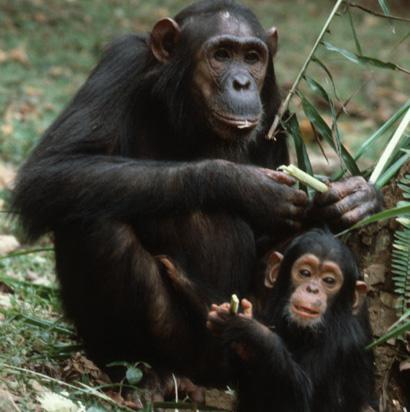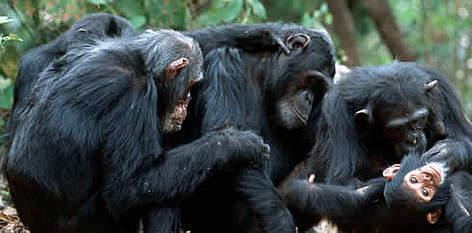The first image is the image on the left, the second image is the image on the right. Assess this claim about the two images: "there is exactly one animal in the image on the left". Correct or not? Answer yes or no. No. The first image is the image on the left, the second image is the image on the right. Given the left and right images, does the statement "An image shows one adult chimp next to a baby chimp, with both faces visible." hold true? Answer yes or no. Yes. 